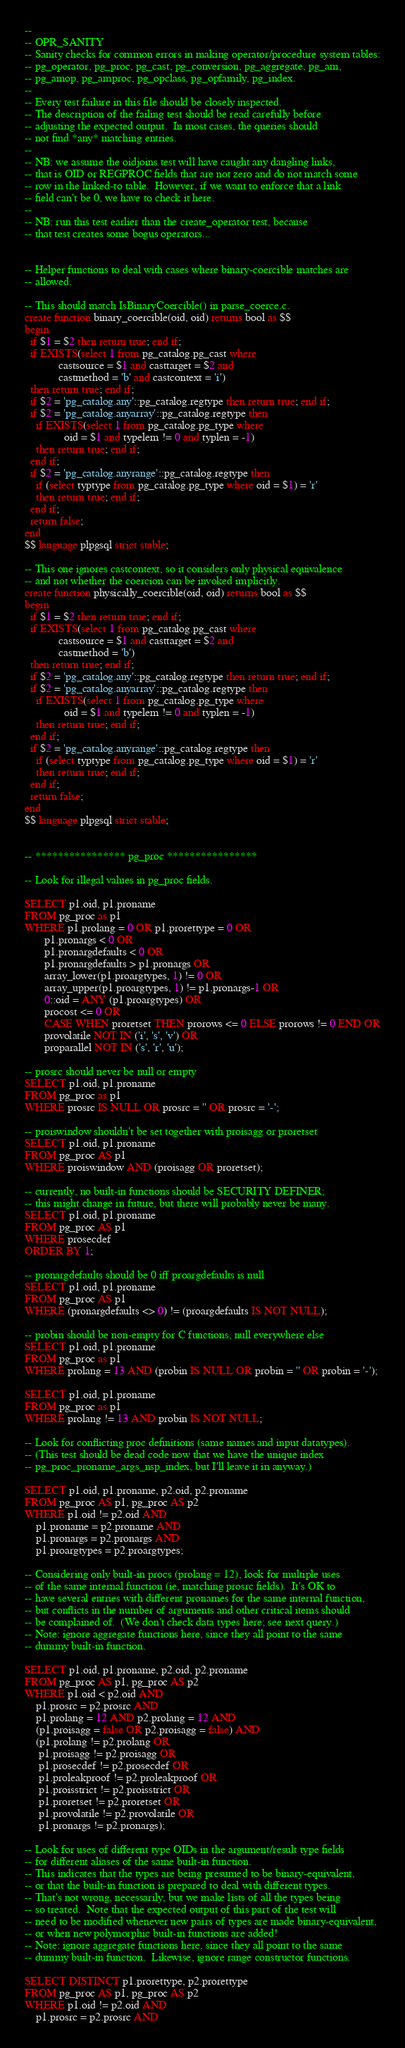<code> <loc_0><loc_0><loc_500><loc_500><_SQL_>--
-- OPR_SANITY
-- Sanity checks for common errors in making operator/procedure system tables:
-- pg_operator, pg_proc, pg_cast, pg_conversion, pg_aggregate, pg_am,
-- pg_amop, pg_amproc, pg_opclass, pg_opfamily, pg_index.
--
-- Every test failure in this file should be closely inspected.
-- The description of the failing test should be read carefully before
-- adjusting the expected output.  In most cases, the queries should
-- not find *any* matching entries.
--
-- NB: we assume the oidjoins test will have caught any dangling links,
-- that is OID or REGPROC fields that are not zero and do not match some
-- row in the linked-to table.  However, if we want to enforce that a link
-- field can't be 0, we have to check it here.
--
-- NB: run this test earlier than the create_operator test, because
-- that test creates some bogus operators...


-- Helper functions to deal with cases where binary-coercible matches are
-- allowed.

-- This should match IsBinaryCoercible() in parse_coerce.c.
create function binary_coercible(oid, oid) returns bool as $$
begin
  if $1 = $2 then return true; end if;
  if EXISTS(select 1 from pg_catalog.pg_cast where
            castsource = $1 and casttarget = $2 and
            castmethod = 'b' and castcontext = 'i')
  then return true; end if;
  if $2 = 'pg_catalog.any'::pg_catalog.regtype then return true; end if;
  if $2 = 'pg_catalog.anyarray'::pg_catalog.regtype then
    if EXISTS(select 1 from pg_catalog.pg_type where
              oid = $1 and typelem != 0 and typlen = -1)
    then return true; end if;
  end if;
  if $2 = 'pg_catalog.anyrange'::pg_catalog.regtype then
    if (select typtype from pg_catalog.pg_type where oid = $1) = 'r'
    then return true; end if;
  end if;
  return false;
end
$$ language plpgsql strict stable;

-- This one ignores castcontext, so it considers only physical equivalence
-- and not whether the coercion can be invoked implicitly.
create function physically_coercible(oid, oid) returns bool as $$
begin
  if $1 = $2 then return true; end if;
  if EXISTS(select 1 from pg_catalog.pg_cast where
            castsource = $1 and casttarget = $2 and
            castmethod = 'b')
  then return true; end if;
  if $2 = 'pg_catalog.any'::pg_catalog.regtype then return true; end if;
  if $2 = 'pg_catalog.anyarray'::pg_catalog.regtype then
    if EXISTS(select 1 from pg_catalog.pg_type where
              oid = $1 and typelem != 0 and typlen = -1)
    then return true; end if;
  end if;
  if $2 = 'pg_catalog.anyrange'::pg_catalog.regtype then
    if (select typtype from pg_catalog.pg_type where oid = $1) = 'r'
    then return true; end if;
  end if;
  return false;
end
$$ language plpgsql strict stable;


-- **************** pg_proc ****************

-- Look for illegal values in pg_proc fields.

SELECT p1.oid, p1.proname
FROM pg_proc as p1
WHERE p1.prolang = 0 OR p1.prorettype = 0 OR
       p1.pronargs < 0 OR
       p1.pronargdefaults < 0 OR
       p1.pronargdefaults > p1.pronargs OR
       array_lower(p1.proargtypes, 1) != 0 OR
       array_upper(p1.proargtypes, 1) != p1.pronargs-1 OR
       0::oid = ANY (p1.proargtypes) OR
       procost <= 0 OR
       CASE WHEN proretset THEN prorows <= 0 ELSE prorows != 0 END OR
       provolatile NOT IN ('i', 's', 'v') OR
       proparallel NOT IN ('s', 'r', 'u');

-- prosrc should never be null or empty
SELECT p1.oid, p1.proname
FROM pg_proc as p1
WHERE prosrc IS NULL OR prosrc = '' OR prosrc = '-';

-- proiswindow shouldn't be set together with proisagg or proretset
SELECT p1.oid, p1.proname
FROM pg_proc AS p1
WHERE proiswindow AND (proisagg OR proretset);

-- currently, no built-in functions should be SECURITY DEFINER;
-- this might change in future, but there will probably never be many.
SELECT p1.oid, p1.proname
FROM pg_proc AS p1
WHERE prosecdef
ORDER BY 1;

-- pronargdefaults should be 0 iff proargdefaults is null
SELECT p1.oid, p1.proname
FROM pg_proc AS p1
WHERE (pronargdefaults <> 0) != (proargdefaults IS NOT NULL);

-- probin should be non-empty for C functions, null everywhere else
SELECT p1.oid, p1.proname
FROM pg_proc as p1
WHERE prolang = 13 AND (probin IS NULL OR probin = '' OR probin = '-');

SELECT p1.oid, p1.proname
FROM pg_proc as p1
WHERE prolang != 13 AND probin IS NOT NULL;

-- Look for conflicting proc definitions (same names and input datatypes).
-- (This test should be dead code now that we have the unique index
-- pg_proc_proname_args_nsp_index, but I'll leave it in anyway.)

SELECT p1.oid, p1.proname, p2.oid, p2.proname
FROM pg_proc AS p1, pg_proc AS p2
WHERE p1.oid != p2.oid AND
    p1.proname = p2.proname AND
    p1.pronargs = p2.pronargs AND
    p1.proargtypes = p2.proargtypes;

-- Considering only built-in procs (prolang = 12), look for multiple uses
-- of the same internal function (ie, matching prosrc fields).  It's OK to
-- have several entries with different pronames for the same internal function,
-- but conflicts in the number of arguments and other critical items should
-- be complained of.  (We don't check data types here; see next query.)
-- Note: ignore aggregate functions here, since they all point to the same
-- dummy built-in function.

SELECT p1.oid, p1.proname, p2.oid, p2.proname
FROM pg_proc AS p1, pg_proc AS p2
WHERE p1.oid < p2.oid AND
    p1.prosrc = p2.prosrc AND
    p1.prolang = 12 AND p2.prolang = 12 AND
    (p1.proisagg = false OR p2.proisagg = false) AND
    (p1.prolang != p2.prolang OR
     p1.proisagg != p2.proisagg OR
     p1.prosecdef != p2.prosecdef OR
     p1.proleakproof != p2.proleakproof OR
     p1.proisstrict != p2.proisstrict OR
     p1.proretset != p2.proretset OR
     p1.provolatile != p2.provolatile OR
     p1.pronargs != p2.pronargs);

-- Look for uses of different type OIDs in the argument/result type fields
-- for different aliases of the same built-in function.
-- This indicates that the types are being presumed to be binary-equivalent,
-- or that the built-in function is prepared to deal with different types.
-- That's not wrong, necessarily, but we make lists of all the types being
-- so treated.  Note that the expected output of this part of the test will
-- need to be modified whenever new pairs of types are made binary-equivalent,
-- or when new polymorphic built-in functions are added!
-- Note: ignore aggregate functions here, since they all point to the same
-- dummy built-in function.  Likewise, ignore range constructor functions.

SELECT DISTINCT p1.prorettype, p2.prorettype
FROM pg_proc AS p1, pg_proc AS p2
WHERE p1.oid != p2.oid AND
    p1.prosrc = p2.prosrc AND</code> 